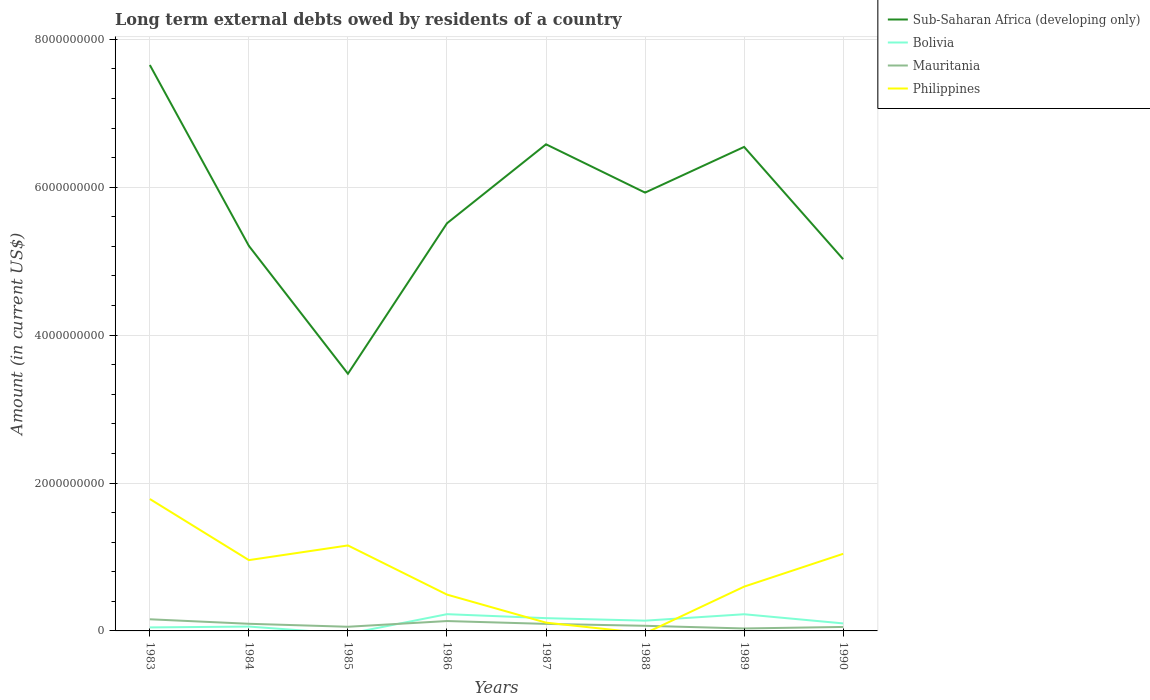How many different coloured lines are there?
Make the answer very short. 4. Does the line corresponding to Bolivia intersect with the line corresponding to Sub-Saharan Africa (developing only)?
Your response must be concise. No. What is the total amount of long-term external debts owed by residents in Bolivia in the graph?
Provide a succinct answer. -1.66e+08. What is the difference between the highest and the second highest amount of long-term external debts owed by residents in Philippines?
Your answer should be compact. 1.78e+09. What is the difference between the highest and the lowest amount of long-term external debts owed by residents in Mauritania?
Ensure brevity in your answer.  4. Is the amount of long-term external debts owed by residents in Sub-Saharan Africa (developing only) strictly greater than the amount of long-term external debts owed by residents in Bolivia over the years?
Provide a succinct answer. No. How many lines are there?
Provide a short and direct response. 4. How many years are there in the graph?
Give a very brief answer. 8. What is the difference between two consecutive major ticks on the Y-axis?
Offer a very short reply. 2.00e+09. Does the graph contain any zero values?
Give a very brief answer. Yes. How many legend labels are there?
Your answer should be compact. 4. How are the legend labels stacked?
Provide a short and direct response. Vertical. What is the title of the graph?
Keep it short and to the point. Long term external debts owed by residents of a country. Does "Isle of Man" appear as one of the legend labels in the graph?
Your answer should be very brief. No. What is the Amount (in current US$) in Sub-Saharan Africa (developing only) in 1983?
Offer a very short reply. 7.65e+09. What is the Amount (in current US$) of Bolivia in 1983?
Your answer should be compact. 4.74e+07. What is the Amount (in current US$) in Mauritania in 1983?
Provide a succinct answer. 1.57e+08. What is the Amount (in current US$) of Philippines in 1983?
Your response must be concise. 1.78e+09. What is the Amount (in current US$) of Sub-Saharan Africa (developing only) in 1984?
Make the answer very short. 5.21e+09. What is the Amount (in current US$) of Bolivia in 1984?
Give a very brief answer. 5.90e+07. What is the Amount (in current US$) in Mauritania in 1984?
Your answer should be compact. 9.66e+07. What is the Amount (in current US$) of Philippines in 1984?
Provide a short and direct response. 9.57e+08. What is the Amount (in current US$) of Sub-Saharan Africa (developing only) in 1985?
Keep it short and to the point. 3.48e+09. What is the Amount (in current US$) of Bolivia in 1985?
Keep it short and to the point. 0. What is the Amount (in current US$) of Mauritania in 1985?
Ensure brevity in your answer.  5.62e+07. What is the Amount (in current US$) in Philippines in 1985?
Your answer should be compact. 1.16e+09. What is the Amount (in current US$) of Sub-Saharan Africa (developing only) in 1986?
Make the answer very short. 5.51e+09. What is the Amount (in current US$) of Bolivia in 1986?
Offer a very short reply. 2.26e+08. What is the Amount (in current US$) in Mauritania in 1986?
Offer a terse response. 1.33e+08. What is the Amount (in current US$) of Philippines in 1986?
Your response must be concise. 4.91e+08. What is the Amount (in current US$) in Sub-Saharan Africa (developing only) in 1987?
Ensure brevity in your answer.  6.58e+09. What is the Amount (in current US$) in Bolivia in 1987?
Your answer should be compact. 1.73e+08. What is the Amount (in current US$) in Mauritania in 1987?
Offer a very short reply. 9.51e+07. What is the Amount (in current US$) of Philippines in 1987?
Offer a terse response. 1.12e+08. What is the Amount (in current US$) of Sub-Saharan Africa (developing only) in 1988?
Your answer should be very brief. 5.93e+09. What is the Amount (in current US$) of Bolivia in 1988?
Make the answer very short. 1.39e+08. What is the Amount (in current US$) of Mauritania in 1988?
Keep it short and to the point. 6.94e+07. What is the Amount (in current US$) in Philippines in 1988?
Give a very brief answer. 0. What is the Amount (in current US$) of Sub-Saharan Africa (developing only) in 1989?
Offer a very short reply. 6.55e+09. What is the Amount (in current US$) of Bolivia in 1989?
Ensure brevity in your answer.  2.25e+08. What is the Amount (in current US$) of Mauritania in 1989?
Provide a short and direct response. 3.32e+07. What is the Amount (in current US$) of Philippines in 1989?
Your answer should be compact. 5.99e+08. What is the Amount (in current US$) of Sub-Saharan Africa (developing only) in 1990?
Offer a very short reply. 5.03e+09. What is the Amount (in current US$) of Bolivia in 1990?
Provide a succinct answer. 1.02e+08. What is the Amount (in current US$) in Mauritania in 1990?
Keep it short and to the point. 5.39e+07. What is the Amount (in current US$) of Philippines in 1990?
Provide a succinct answer. 1.04e+09. Across all years, what is the maximum Amount (in current US$) of Sub-Saharan Africa (developing only)?
Offer a terse response. 7.65e+09. Across all years, what is the maximum Amount (in current US$) in Bolivia?
Provide a short and direct response. 2.26e+08. Across all years, what is the maximum Amount (in current US$) in Mauritania?
Offer a very short reply. 1.57e+08. Across all years, what is the maximum Amount (in current US$) in Philippines?
Keep it short and to the point. 1.78e+09. Across all years, what is the minimum Amount (in current US$) in Sub-Saharan Africa (developing only)?
Keep it short and to the point. 3.48e+09. Across all years, what is the minimum Amount (in current US$) of Bolivia?
Keep it short and to the point. 0. Across all years, what is the minimum Amount (in current US$) of Mauritania?
Your answer should be compact. 3.32e+07. What is the total Amount (in current US$) of Sub-Saharan Africa (developing only) in the graph?
Ensure brevity in your answer.  4.59e+1. What is the total Amount (in current US$) in Bolivia in the graph?
Make the answer very short. 9.71e+08. What is the total Amount (in current US$) in Mauritania in the graph?
Your response must be concise. 6.95e+08. What is the total Amount (in current US$) in Philippines in the graph?
Your answer should be very brief. 6.14e+09. What is the difference between the Amount (in current US$) of Sub-Saharan Africa (developing only) in 1983 and that in 1984?
Your answer should be very brief. 2.45e+09. What is the difference between the Amount (in current US$) in Bolivia in 1983 and that in 1984?
Ensure brevity in your answer.  -1.16e+07. What is the difference between the Amount (in current US$) of Mauritania in 1983 and that in 1984?
Make the answer very short. 6.09e+07. What is the difference between the Amount (in current US$) of Philippines in 1983 and that in 1984?
Your answer should be very brief. 8.26e+08. What is the difference between the Amount (in current US$) of Sub-Saharan Africa (developing only) in 1983 and that in 1985?
Your answer should be very brief. 4.17e+09. What is the difference between the Amount (in current US$) of Mauritania in 1983 and that in 1985?
Your answer should be very brief. 1.01e+08. What is the difference between the Amount (in current US$) in Philippines in 1983 and that in 1985?
Keep it short and to the point. 6.28e+08. What is the difference between the Amount (in current US$) in Sub-Saharan Africa (developing only) in 1983 and that in 1986?
Provide a short and direct response. 2.14e+09. What is the difference between the Amount (in current US$) of Bolivia in 1983 and that in 1986?
Ensure brevity in your answer.  -1.79e+08. What is the difference between the Amount (in current US$) of Mauritania in 1983 and that in 1986?
Your answer should be very brief. 2.40e+07. What is the difference between the Amount (in current US$) in Philippines in 1983 and that in 1986?
Provide a short and direct response. 1.29e+09. What is the difference between the Amount (in current US$) of Sub-Saharan Africa (developing only) in 1983 and that in 1987?
Provide a short and direct response. 1.07e+09. What is the difference between the Amount (in current US$) in Bolivia in 1983 and that in 1987?
Offer a terse response. -1.25e+08. What is the difference between the Amount (in current US$) of Mauritania in 1983 and that in 1987?
Ensure brevity in your answer.  6.23e+07. What is the difference between the Amount (in current US$) of Philippines in 1983 and that in 1987?
Your answer should be compact. 1.67e+09. What is the difference between the Amount (in current US$) of Sub-Saharan Africa (developing only) in 1983 and that in 1988?
Make the answer very short. 1.73e+09. What is the difference between the Amount (in current US$) of Bolivia in 1983 and that in 1988?
Ensure brevity in your answer.  -9.14e+07. What is the difference between the Amount (in current US$) of Mauritania in 1983 and that in 1988?
Offer a very short reply. 8.81e+07. What is the difference between the Amount (in current US$) of Sub-Saharan Africa (developing only) in 1983 and that in 1989?
Make the answer very short. 1.11e+09. What is the difference between the Amount (in current US$) in Bolivia in 1983 and that in 1989?
Make the answer very short. -1.78e+08. What is the difference between the Amount (in current US$) of Mauritania in 1983 and that in 1989?
Offer a terse response. 1.24e+08. What is the difference between the Amount (in current US$) of Philippines in 1983 and that in 1989?
Make the answer very short. 1.18e+09. What is the difference between the Amount (in current US$) in Sub-Saharan Africa (developing only) in 1983 and that in 1990?
Provide a succinct answer. 2.63e+09. What is the difference between the Amount (in current US$) of Bolivia in 1983 and that in 1990?
Provide a succinct answer. -5.42e+07. What is the difference between the Amount (in current US$) in Mauritania in 1983 and that in 1990?
Your answer should be very brief. 1.04e+08. What is the difference between the Amount (in current US$) of Philippines in 1983 and that in 1990?
Provide a short and direct response. 7.41e+08. What is the difference between the Amount (in current US$) in Sub-Saharan Africa (developing only) in 1984 and that in 1985?
Offer a very short reply. 1.73e+09. What is the difference between the Amount (in current US$) of Mauritania in 1984 and that in 1985?
Ensure brevity in your answer.  4.04e+07. What is the difference between the Amount (in current US$) of Philippines in 1984 and that in 1985?
Your response must be concise. -1.98e+08. What is the difference between the Amount (in current US$) in Sub-Saharan Africa (developing only) in 1984 and that in 1986?
Offer a terse response. -3.06e+08. What is the difference between the Amount (in current US$) in Bolivia in 1984 and that in 1986?
Give a very brief answer. -1.67e+08. What is the difference between the Amount (in current US$) of Mauritania in 1984 and that in 1986?
Ensure brevity in your answer.  -3.69e+07. What is the difference between the Amount (in current US$) in Philippines in 1984 and that in 1986?
Offer a terse response. 4.66e+08. What is the difference between the Amount (in current US$) in Sub-Saharan Africa (developing only) in 1984 and that in 1987?
Make the answer very short. -1.37e+09. What is the difference between the Amount (in current US$) of Bolivia in 1984 and that in 1987?
Offer a very short reply. -1.14e+08. What is the difference between the Amount (in current US$) in Mauritania in 1984 and that in 1987?
Make the answer very short. 1.46e+06. What is the difference between the Amount (in current US$) in Philippines in 1984 and that in 1987?
Provide a succinct answer. 8.46e+08. What is the difference between the Amount (in current US$) in Sub-Saharan Africa (developing only) in 1984 and that in 1988?
Your answer should be compact. -7.21e+08. What is the difference between the Amount (in current US$) of Bolivia in 1984 and that in 1988?
Your answer should be very brief. -7.97e+07. What is the difference between the Amount (in current US$) of Mauritania in 1984 and that in 1988?
Give a very brief answer. 2.72e+07. What is the difference between the Amount (in current US$) in Sub-Saharan Africa (developing only) in 1984 and that in 1989?
Offer a terse response. -1.34e+09. What is the difference between the Amount (in current US$) in Bolivia in 1984 and that in 1989?
Make the answer very short. -1.66e+08. What is the difference between the Amount (in current US$) of Mauritania in 1984 and that in 1989?
Keep it short and to the point. 6.34e+07. What is the difference between the Amount (in current US$) in Philippines in 1984 and that in 1989?
Make the answer very short. 3.59e+08. What is the difference between the Amount (in current US$) of Sub-Saharan Africa (developing only) in 1984 and that in 1990?
Your response must be concise. 1.80e+08. What is the difference between the Amount (in current US$) in Bolivia in 1984 and that in 1990?
Your answer should be very brief. -4.25e+07. What is the difference between the Amount (in current US$) in Mauritania in 1984 and that in 1990?
Keep it short and to the point. 4.27e+07. What is the difference between the Amount (in current US$) in Philippines in 1984 and that in 1990?
Your answer should be very brief. -8.54e+07. What is the difference between the Amount (in current US$) in Sub-Saharan Africa (developing only) in 1985 and that in 1986?
Provide a succinct answer. -2.03e+09. What is the difference between the Amount (in current US$) in Mauritania in 1985 and that in 1986?
Offer a very short reply. -7.73e+07. What is the difference between the Amount (in current US$) in Philippines in 1985 and that in 1986?
Provide a short and direct response. 6.65e+08. What is the difference between the Amount (in current US$) of Sub-Saharan Africa (developing only) in 1985 and that in 1987?
Offer a terse response. -3.10e+09. What is the difference between the Amount (in current US$) of Mauritania in 1985 and that in 1987?
Provide a short and direct response. -3.89e+07. What is the difference between the Amount (in current US$) in Philippines in 1985 and that in 1987?
Your answer should be very brief. 1.04e+09. What is the difference between the Amount (in current US$) in Sub-Saharan Africa (developing only) in 1985 and that in 1988?
Ensure brevity in your answer.  -2.45e+09. What is the difference between the Amount (in current US$) in Mauritania in 1985 and that in 1988?
Keep it short and to the point. -1.32e+07. What is the difference between the Amount (in current US$) of Sub-Saharan Africa (developing only) in 1985 and that in 1989?
Give a very brief answer. -3.07e+09. What is the difference between the Amount (in current US$) of Mauritania in 1985 and that in 1989?
Give a very brief answer. 2.30e+07. What is the difference between the Amount (in current US$) in Philippines in 1985 and that in 1989?
Ensure brevity in your answer.  5.57e+08. What is the difference between the Amount (in current US$) of Sub-Saharan Africa (developing only) in 1985 and that in 1990?
Offer a very short reply. -1.55e+09. What is the difference between the Amount (in current US$) in Mauritania in 1985 and that in 1990?
Give a very brief answer. 2.29e+06. What is the difference between the Amount (in current US$) in Philippines in 1985 and that in 1990?
Ensure brevity in your answer.  1.13e+08. What is the difference between the Amount (in current US$) in Sub-Saharan Africa (developing only) in 1986 and that in 1987?
Your answer should be compact. -1.07e+09. What is the difference between the Amount (in current US$) of Bolivia in 1986 and that in 1987?
Offer a terse response. 5.38e+07. What is the difference between the Amount (in current US$) of Mauritania in 1986 and that in 1987?
Give a very brief answer. 3.84e+07. What is the difference between the Amount (in current US$) of Philippines in 1986 and that in 1987?
Ensure brevity in your answer.  3.79e+08. What is the difference between the Amount (in current US$) of Sub-Saharan Africa (developing only) in 1986 and that in 1988?
Offer a very short reply. -4.15e+08. What is the difference between the Amount (in current US$) of Bolivia in 1986 and that in 1988?
Keep it short and to the point. 8.76e+07. What is the difference between the Amount (in current US$) in Mauritania in 1986 and that in 1988?
Your response must be concise. 6.41e+07. What is the difference between the Amount (in current US$) in Sub-Saharan Africa (developing only) in 1986 and that in 1989?
Keep it short and to the point. -1.03e+09. What is the difference between the Amount (in current US$) in Bolivia in 1986 and that in 1989?
Keep it short and to the point. 9.31e+05. What is the difference between the Amount (in current US$) of Mauritania in 1986 and that in 1989?
Your answer should be compact. 1.00e+08. What is the difference between the Amount (in current US$) in Philippines in 1986 and that in 1989?
Keep it short and to the point. -1.08e+08. What is the difference between the Amount (in current US$) of Sub-Saharan Africa (developing only) in 1986 and that in 1990?
Make the answer very short. 4.86e+08. What is the difference between the Amount (in current US$) of Bolivia in 1986 and that in 1990?
Make the answer very short. 1.25e+08. What is the difference between the Amount (in current US$) of Mauritania in 1986 and that in 1990?
Keep it short and to the point. 7.96e+07. What is the difference between the Amount (in current US$) of Philippines in 1986 and that in 1990?
Provide a short and direct response. -5.52e+08. What is the difference between the Amount (in current US$) in Sub-Saharan Africa (developing only) in 1987 and that in 1988?
Keep it short and to the point. 6.53e+08. What is the difference between the Amount (in current US$) of Bolivia in 1987 and that in 1988?
Your answer should be very brief. 3.38e+07. What is the difference between the Amount (in current US$) in Mauritania in 1987 and that in 1988?
Provide a short and direct response. 2.57e+07. What is the difference between the Amount (in current US$) in Sub-Saharan Africa (developing only) in 1987 and that in 1989?
Offer a terse response. 3.54e+07. What is the difference between the Amount (in current US$) in Bolivia in 1987 and that in 1989?
Your answer should be very brief. -5.29e+07. What is the difference between the Amount (in current US$) in Mauritania in 1987 and that in 1989?
Ensure brevity in your answer.  6.19e+07. What is the difference between the Amount (in current US$) of Philippines in 1987 and that in 1989?
Provide a succinct answer. -4.87e+08. What is the difference between the Amount (in current US$) of Sub-Saharan Africa (developing only) in 1987 and that in 1990?
Make the answer very short. 1.55e+09. What is the difference between the Amount (in current US$) in Bolivia in 1987 and that in 1990?
Provide a succinct answer. 7.10e+07. What is the difference between the Amount (in current US$) of Mauritania in 1987 and that in 1990?
Provide a succinct answer. 4.12e+07. What is the difference between the Amount (in current US$) of Philippines in 1987 and that in 1990?
Your answer should be very brief. -9.31e+08. What is the difference between the Amount (in current US$) in Sub-Saharan Africa (developing only) in 1988 and that in 1989?
Provide a succinct answer. -6.18e+08. What is the difference between the Amount (in current US$) in Bolivia in 1988 and that in 1989?
Provide a succinct answer. -8.67e+07. What is the difference between the Amount (in current US$) of Mauritania in 1988 and that in 1989?
Offer a terse response. 3.62e+07. What is the difference between the Amount (in current US$) of Sub-Saharan Africa (developing only) in 1988 and that in 1990?
Your answer should be compact. 9.01e+08. What is the difference between the Amount (in current US$) of Bolivia in 1988 and that in 1990?
Your answer should be compact. 3.72e+07. What is the difference between the Amount (in current US$) in Mauritania in 1988 and that in 1990?
Make the answer very short. 1.55e+07. What is the difference between the Amount (in current US$) in Sub-Saharan Africa (developing only) in 1989 and that in 1990?
Ensure brevity in your answer.  1.52e+09. What is the difference between the Amount (in current US$) in Bolivia in 1989 and that in 1990?
Provide a succinct answer. 1.24e+08. What is the difference between the Amount (in current US$) of Mauritania in 1989 and that in 1990?
Your response must be concise. -2.08e+07. What is the difference between the Amount (in current US$) of Philippines in 1989 and that in 1990?
Give a very brief answer. -4.44e+08. What is the difference between the Amount (in current US$) in Sub-Saharan Africa (developing only) in 1983 and the Amount (in current US$) in Bolivia in 1984?
Ensure brevity in your answer.  7.59e+09. What is the difference between the Amount (in current US$) of Sub-Saharan Africa (developing only) in 1983 and the Amount (in current US$) of Mauritania in 1984?
Ensure brevity in your answer.  7.56e+09. What is the difference between the Amount (in current US$) of Sub-Saharan Africa (developing only) in 1983 and the Amount (in current US$) of Philippines in 1984?
Provide a short and direct response. 6.70e+09. What is the difference between the Amount (in current US$) in Bolivia in 1983 and the Amount (in current US$) in Mauritania in 1984?
Provide a short and direct response. -4.92e+07. What is the difference between the Amount (in current US$) in Bolivia in 1983 and the Amount (in current US$) in Philippines in 1984?
Your answer should be compact. -9.10e+08. What is the difference between the Amount (in current US$) in Mauritania in 1983 and the Amount (in current US$) in Philippines in 1984?
Ensure brevity in your answer.  -8.00e+08. What is the difference between the Amount (in current US$) of Sub-Saharan Africa (developing only) in 1983 and the Amount (in current US$) of Mauritania in 1985?
Give a very brief answer. 7.60e+09. What is the difference between the Amount (in current US$) of Sub-Saharan Africa (developing only) in 1983 and the Amount (in current US$) of Philippines in 1985?
Your answer should be compact. 6.50e+09. What is the difference between the Amount (in current US$) of Bolivia in 1983 and the Amount (in current US$) of Mauritania in 1985?
Keep it short and to the point. -8.82e+06. What is the difference between the Amount (in current US$) in Bolivia in 1983 and the Amount (in current US$) in Philippines in 1985?
Make the answer very short. -1.11e+09. What is the difference between the Amount (in current US$) of Mauritania in 1983 and the Amount (in current US$) of Philippines in 1985?
Provide a succinct answer. -9.98e+08. What is the difference between the Amount (in current US$) of Sub-Saharan Africa (developing only) in 1983 and the Amount (in current US$) of Bolivia in 1986?
Provide a succinct answer. 7.43e+09. What is the difference between the Amount (in current US$) of Sub-Saharan Africa (developing only) in 1983 and the Amount (in current US$) of Mauritania in 1986?
Keep it short and to the point. 7.52e+09. What is the difference between the Amount (in current US$) of Sub-Saharan Africa (developing only) in 1983 and the Amount (in current US$) of Philippines in 1986?
Your answer should be compact. 7.16e+09. What is the difference between the Amount (in current US$) of Bolivia in 1983 and the Amount (in current US$) of Mauritania in 1986?
Your answer should be compact. -8.61e+07. What is the difference between the Amount (in current US$) in Bolivia in 1983 and the Amount (in current US$) in Philippines in 1986?
Your response must be concise. -4.44e+08. What is the difference between the Amount (in current US$) in Mauritania in 1983 and the Amount (in current US$) in Philippines in 1986?
Provide a succinct answer. -3.34e+08. What is the difference between the Amount (in current US$) in Sub-Saharan Africa (developing only) in 1983 and the Amount (in current US$) in Bolivia in 1987?
Your answer should be very brief. 7.48e+09. What is the difference between the Amount (in current US$) of Sub-Saharan Africa (developing only) in 1983 and the Amount (in current US$) of Mauritania in 1987?
Your answer should be compact. 7.56e+09. What is the difference between the Amount (in current US$) of Sub-Saharan Africa (developing only) in 1983 and the Amount (in current US$) of Philippines in 1987?
Offer a very short reply. 7.54e+09. What is the difference between the Amount (in current US$) of Bolivia in 1983 and the Amount (in current US$) of Mauritania in 1987?
Offer a terse response. -4.77e+07. What is the difference between the Amount (in current US$) of Bolivia in 1983 and the Amount (in current US$) of Philippines in 1987?
Your response must be concise. -6.44e+07. What is the difference between the Amount (in current US$) in Mauritania in 1983 and the Amount (in current US$) in Philippines in 1987?
Your answer should be compact. 4.56e+07. What is the difference between the Amount (in current US$) of Sub-Saharan Africa (developing only) in 1983 and the Amount (in current US$) of Bolivia in 1988?
Offer a terse response. 7.51e+09. What is the difference between the Amount (in current US$) of Sub-Saharan Africa (developing only) in 1983 and the Amount (in current US$) of Mauritania in 1988?
Give a very brief answer. 7.58e+09. What is the difference between the Amount (in current US$) of Bolivia in 1983 and the Amount (in current US$) of Mauritania in 1988?
Offer a terse response. -2.20e+07. What is the difference between the Amount (in current US$) of Sub-Saharan Africa (developing only) in 1983 and the Amount (in current US$) of Bolivia in 1989?
Offer a terse response. 7.43e+09. What is the difference between the Amount (in current US$) in Sub-Saharan Africa (developing only) in 1983 and the Amount (in current US$) in Mauritania in 1989?
Provide a succinct answer. 7.62e+09. What is the difference between the Amount (in current US$) in Sub-Saharan Africa (developing only) in 1983 and the Amount (in current US$) in Philippines in 1989?
Provide a short and direct response. 7.05e+09. What is the difference between the Amount (in current US$) in Bolivia in 1983 and the Amount (in current US$) in Mauritania in 1989?
Offer a terse response. 1.42e+07. What is the difference between the Amount (in current US$) of Bolivia in 1983 and the Amount (in current US$) of Philippines in 1989?
Ensure brevity in your answer.  -5.52e+08. What is the difference between the Amount (in current US$) of Mauritania in 1983 and the Amount (in current US$) of Philippines in 1989?
Your answer should be compact. -4.41e+08. What is the difference between the Amount (in current US$) in Sub-Saharan Africa (developing only) in 1983 and the Amount (in current US$) in Bolivia in 1990?
Offer a very short reply. 7.55e+09. What is the difference between the Amount (in current US$) in Sub-Saharan Africa (developing only) in 1983 and the Amount (in current US$) in Mauritania in 1990?
Offer a terse response. 7.60e+09. What is the difference between the Amount (in current US$) in Sub-Saharan Africa (developing only) in 1983 and the Amount (in current US$) in Philippines in 1990?
Offer a terse response. 6.61e+09. What is the difference between the Amount (in current US$) of Bolivia in 1983 and the Amount (in current US$) of Mauritania in 1990?
Your answer should be very brief. -6.53e+06. What is the difference between the Amount (in current US$) of Bolivia in 1983 and the Amount (in current US$) of Philippines in 1990?
Your answer should be very brief. -9.95e+08. What is the difference between the Amount (in current US$) in Mauritania in 1983 and the Amount (in current US$) in Philippines in 1990?
Your answer should be compact. -8.85e+08. What is the difference between the Amount (in current US$) in Sub-Saharan Africa (developing only) in 1984 and the Amount (in current US$) in Mauritania in 1985?
Your answer should be compact. 5.15e+09. What is the difference between the Amount (in current US$) in Sub-Saharan Africa (developing only) in 1984 and the Amount (in current US$) in Philippines in 1985?
Make the answer very short. 4.05e+09. What is the difference between the Amount (in current US$) in Bolivia in 1984 and the Amount (in current US$) in Mauritania in 1985?
Give a very brief answer. 2.83e+06. What is the difference between the Amount (in current US$) in Bolivia in 1984 and the Amount (in current US$) in Philippines in 1985?
Your response must be concise. -1.10e+09. What is the difference between the Amount (in current US$) of Mauritania in 1984 and the Amount (in current US$) of Philippines in 1985?
Ensure brevity in your answer.  -1.06e+09. What is the difference between the Amount (in current US$) of Sub-Saharan Africa (developing only) in 1984 and the Amount (in current US$) of Bolivia in 1986?
Keep it short and to the point. 4.98e+09. What is the difference between the Amount (in current US$) in Sub-Saharan Africa (developing only) in 1984 and the Amount (in current US$) in Mauritania in 1986?
Ensure brevity in your answer.  5.07e+09. What is the difference between the Amount (in current US$) in Sub-Saharan Africa (developing only) in 1984 and the Amount (in current US$) in Philippines in 1986?
Offer a very short reply. 4.72e+09. What is the difference between the Amount (in current US$) of Bolivia in 1984 and the Amount (in current US$) of Mauritania in 1986?
Give a very brief answer. -7.44e+07. What is the difference between the Amount (in current US$) of Bolivia in 1984 and the Amount (in current US$) of Philippines in 1986?
Offer a very short reply. -4.32e+08. What is the difference between the Amount (in current US$) of Mauritania in 1984 and the Amount (in current US$) of Philippines in 1986?
Make the answer very short. -3.94e+08. What is the difference between the Amount (in current US$) of Sub-Saharan Africa (developing only) in 1984 and the Amount (in current US$) of Bolivia in 1987?
Your answer should be very brief. 5.03e+09. What is the difference between the Amount (in current US$) in Sub-Saharan Africa (developing only) in 1984 and the Amount (in current US$) in Mauritania in 1987?
Ensure brevity in your answer.  5.11e+09. What is the difference between the Amount (in current US$) of Sub-Saharan Africa (developing only) in 1984 and the Amount (in current US$) of Philippines in 1987?
Provide a succinct answer. 5.09e+09. What is the difference between the Amount (in current US$) of Bolivia in 1984 and the Amount (in current US$) of Mauritania in 1987?
Your response must be concise. -3.61e+07. What is the difference between the Amount (in current US$) of Bolivia in 1984 and the Amount (in current US$) of Philippines in 1987?
Your answer should be compact. -5.28e+07. What is the difference between the Amount (in current US$) of Mauritania in 1984 and the Amount (in current US$) of Philippines in 1987?
Make the answer very short. -1.52e+07. What is the difference between the Amount (in current US$) of Sub-Saharan Africa (developing only) in 1984 and the Amount (in current US$) of Bolivia in 1988?
Keep it short and to the point. 5.07e+09. What is the difference between the Amount (in current US$) of Sub-Saharan Africa (developing only) in 1984 and the Amount (in current US$) of Mauritania in 1988?
Ensure brevity in your answer.  5.14e+09. What is the difference between the Amount (in current US$) in Bolivia in 1984 and the Amount (in current US$) in Mauritania in 1988?
Your answer should be compact. -1.04e+07. What is the difference between the Amount (in current US$) in Sub-Saharan Africa (developing only) in 1984 and the Amount (in current US$) in Bolivia in 1989?
Your answer should be compact. 4.98e+09. What is the difference between the Amount (in current US$) of Sub-Saharan Africa (developing only) in 1984 and the Amount (in current US$) of Mauritania in 1989?
Offer a very short reply. 5.17e+09. What is the difference between the Amount (in current US$) in Sub-Saharan Africa (developing only) in 1984 and the Amount (in current US$) in Philippines in 1989?
Give a very brief answer. 4.61e+09. What is the difference between the Amount (in current US$) in Bolivia in 1984 and the Amount (in current US$) in Mauritania in 1989?
Ensure brevity in your answer.  2.59e+07. What is the difference between the Amount (in current US$) in Bolivia in 1984 and the Amount (in current US$) in Philippines in 1989?
Offer a terse response. -5.40e+08. What is the difference between the Amount (in current US$) in Mauritania in 1984 and the Amount (in current US$) in Philippines in 1989?
Ensure brevity in your answer.  -5.02e+08. What is the difference between the Amount (in current US$) in Sub-Saharan Africa (developing only) in 1984 and the Amount (in current US$) in Bolivia in 1990?
Provide a succinct answer. 5.10e+09. What is the difference between the Amount (in current US$) of Sub-Saharan Africa (developing only) in 1984 and the Amount (in current US$) of Mauritania in 1990?
Provide a succinct answer. 5.15e+09. What is the difference between the Amount (in current US$) of Sub-Saharan Africa (developing only) in 1984 and the Amount (in current US$) of Philippines in 1990?
Your answer should be compact. 4.16e+09. What is the difference between the Amount (in current US$) in Bolivia in 1984 and the Amount (in current US$) in Mauritania in 1990?
Provide a short and direct response. 5.12e+06. What is the difference between the Amount (in current US$) in Bolivia in 1984 and the Amount (in current US$) in Philippines in 1990?
Offer a terse response. -9.84e+08. What is the difference between the Amount (in current US$) of Mauritania in 1984 and the Amount (in current US$) of Philippines in 1990?
Your answer should be compact. -9.46e+08. What is the difference between the Amount (in current US$) of Sub-Saharan Africa (developing only) in 1985 and the Amount (in current US$) of Bolivia in 1986?
Offer a very short reply. 3.25e+09. What is the difference between the Amount (in current US$) of Sub-Saharan Africa (developing only) in 1985 and the Amount (in current US$) of Mauritania in 1986?
Offer a terse response. 3.34e+09. What is the difference between the Amount (in current US$) in Sub-Saharan Africa (developing only) in 1985 and the Amount (in current US$) in Philippines in 1986?
Your response must be concise. 2.99e+09. What is the difference between the Amount (in current US$) in Mauritania in 1985 and the Amount (in current US$) in Philippines in 1986?
Provide a succinct answer. -4.35e+08. What is the difference between the Amount (in current US$) of Sub-Saharan Africa (developing only) in 1985 and the Amount (in current US$) of Bolivia in 1987?
Offer a very short reply. 3.31e+09. What is the difference between the Amount (in current US$) in Sub-Saharan Africa (developing only) in 1985 and the Amount (in current US$) in Mauritania in 1987?
Offer a terse response. 3.38e+09. What is the difference between the Amount (in current US$) of Sub-Saharan Africa (developing only) in 1985 and the Amount (in current US$) of Philippines in 1987?
Your response must be concise. 3.37e+09. What is the difference between the Amount (in current US$) in Mauritania in 1985 and the Amount (in current US$) in Philippines in 1987?
Provide a short and direct response. -5.56e+07. What is the difference between the Amount (in current US$) of Sub-Saharan Africa (developing only) in 1985 and the Amount (in current US$) of Bolivia in 1988?
Ensure brevity in your answer.  3.34e+09. What is the difference between the Amount (in current US$) in Sub-Saharan Africa (developing only) in 1985 and the Amount (in current US$) in Mauritania in 1988?
Make the answer very short. 3.41e+09. What is the difference between the Amount (in current US$) in Sub-Saharan Africa (developing only) in 1985 and the Amount (in current US$) in Bolivia in 1989?
Provide a succinct answer. 3.25e+09. What is the difference between the Amount (in current US$) in Sub-Saharan Africa (developing only) in 1985 and the Amount (in current US$) in Mauritania in 1989?
Offer a terse response. 3.44e+09. What is the difference between the Amount (in current US$) in Sub-Saharan Africa (developing only) in 1985 and the Amount (in current US$) in Philippines in 1989?
Keep it short and to the point. 2.88e+09. What is the difference between the Amount (in current US$) of Mauritania in 1985 and the Amount (in current US$) of Philippines in 1989?
Your answer should be compact. -5.43e+08. What is the difference between the Amount (in current US$) in Sub-Saharan Africa (developing only) in 1985 and the Amount (in current US$) in Bolivia in 1990?
Your answer should be compact. 3.38e+09. What is the difference between the Amount (in current US$) in Sub-Saharan Africa (developing only) in 1985 and the Amount (in current US$) in Mauritania in 1990?
Your answer should be very brief. 3.42e+09. What is the difference between the Amount (in current US$) of Sub-Saharan Africa (developing only) in 1985 and the Amount (in current US$) of Philippines in 1990?
Your answer should be compact. 2.44e+09. What is the difference between the Amount (in current US$) in Mauritania in 1985 and the Amount (in current US$) in Philippines in 1990?
Your response must be concise. -9.87e+08. What is the difference between the Amount (in current US$) in Sub-Saharan Africa (developing only) in 1986 and the Amount (in current US$) in Bolivia in 1987?
Your answer should be very brief. 5.34e+09. What is the difference between the Amount (in current US$) of Sub-Saharan Africa (developing only) in 1986 and the Amount (in current US$) of Mauritania in 1987?
Provide a short and direct response. 5.42e+09. What is the difference between the Amount (in current US$) of Sub-Saharan Africa (developing only) in 1986 and the Amount (in current US$) of Philippines in 1987?
Provide a succinct answer. 5.40e+09. What is the difference between the Amount (in current US$) of Bolivia in 1986 and the Amount (in current US$) of Mauritania in 1987?
Ensure brevity in your answer.  1.31e+08. What is the difference between the Amount (in current US$) of Bolivia in 1986 and the Amount (in current US$) of Philippines in 1987?
Your response must be concise. 1.15e+08. What is the difference between the Amount (in current US$) of Mauritania in 1986 and the Amount (in current US$) of Philippines in 1987?
Keep it short and to the point. 2.17e+07. What is the difference between the Amount (in current US$) of Sub-Saharan Africa (developing only) in 1986 and the Amount (in current US$) of Bolivia in 1988?
Keep it short and to the point. 5.37e+09. What is the difference between the Amount (in current US$) in Sub-Saharan Africa (developing only) in 1986 and the Amount (in current US$) in Mauritania in 1988?
Make the answer very short. 5.44e+09. What is the difference between the Amount (in current US$) in Bolivia in 1986 and the Amount (in current US$) in Mauritania in 1988?
Your response must be concise. 1.57e+08. What is the difference between the Amount (in current US$) in Sub-Saharan Africa (developing only) in 1986 and the Amount (in current US$) in Bolivia in 1989?
Your answer should be compact. 5.29e+09. What is the difference between the Amount (in current US$) in Sub-Saharan Africa (developing only) in 1986 and the Amount (in current US$) in Mauritania in 1989?
Offer a very short reply. 5.48e+09. What is the difference between the Amount (in current US$) of Sub-Saharan Africa (developing only) in 1986 and the Amount (in current US$) of Philippines in 1989?
Your response must be concise. 4.91e+09. What is the difference between the Amount (in current US$) of Bolivia in 1986 and the Amount (in current US$) of Mauritania in 1989?
Offer a very short reply. 1.93e+08. What is the difference between the Amount (in current US$) in Bolivia in 1986 and the Amount (in current US$) in Philippines in 1989?
Your answer should be very brief. -3.73e+08. What is the difference between the Amount (in current US$) of Mauritania in 1986 and the Amount (in current US$) of Philippines in 1989?
Provide a succinct answer. -4.65e+08. What is the difference between the Amount (in current US$) of Sub-Saharan Africa (developing only) in 1986 and the Amount (in current US$) of Bolivia in 1990?
Ensure brevity in your answer.  5.41e+09. What is the difference between the Amount (in current US$) in Sub-Saharan Africa (developing only) in 1986 and the Amount (in current US$) in Mauritania in 1990?
Your answer should be very brief. 5.46e+09. What is the difference between the Amount (in current US$) in Sub-Saharan Africa (developing only) in 1986 and the Amount (in current US$) in Philippines in 1990?
Offer a terse response. 4.47e+09. What is the difference between the Amount (in current US$) of Bolivia in 1986 and the Amount (in current US$) of Mauritania in 1990?
Your answer should be very brief. 1.72e+08. What is the difference between the Amount (in current US$) in Bolivia in 1986 and the Amount (in current US$) in Philippines in 1990?
Give a very brief answer. -8.16e+08. What is the difference between the Amount (in current US$) in Mauritania in 1986 and the Amount (in current US$) in Philippines in 1990?
Give a very brief answer. -9.09e+08. What is the difference between the Amount (in current US$) of Sub-Saharan Africa (developing only) in 1987 and the Amount (in current US$) of Bolivia in 1988?
Give a very brief answer. 6.44e+09. What is the difference between the Amount (in current US$) of Sub-Saharan Africa (developing only) in 1987 and the Amount (in current US$) of Mauritania in 1988?
Your answer should be compact. 6.51e+09. What is the difference between the Amount (in current US$) of Bolivia in 1987 and the Amount (in current US$) of Mauritania in 1988?
Your answer should be compact. 1.03e+08. What is the difference between the Amount (in current US$) of Sub-Saharan Africa (developing only) in 1987 and the Amount (in current US$) of Bolivia in 1989?
Ensure brevity in your answer.  6.36e+09. What is the difference between the Amount (in current US$) in Sub-Saharan Africa (developing only) in 1987 and the Amount (in current US$) in Mauritania in 1989?
Make the answer very short. 6.55e+09. What is the difference between the Amount (in current US$) in Sub-Saharan Africa (developing only) in 1987 and the Amount (in current US$) in Philippines in 1989?
Ensure brevity in your answer.  5.98e+09. What is the difference between the Amount (in current US$) in Bolivia in 1987 and the Amount (in current US$) in Mauritania in 1989?
Offer a very short reply. 1.39e+08. What is the difference between the Amount (in current US$) of Bolivia in 1987 and the Amount (in current US$) of Philippines in 1989?
Offer a terse response. -4.26e+08. What is the difference between the Amount (in current US$) of Mauritania in 1987 and the Amount (in current US$) of Philippines in 1989?
Ensure brevity in your answer.  -5.04e+08. What is the difference between the Amount (in current US$) of Sub-Saharan Africa (developing only) in 1987 and the Amount (in current US$) of Bolivia in 1990?
Your answer should be very brief. 6.48e+09. What is the difference between the Amount (in current US$) in Sub-Saharan Africa (developing only) in 1987 and the Amount (in current US$) in Mauritania in 1990?
Your answer should be very brief. 6.53e+09. What is the difference between the Amount (in current US$) in Sub-Saharan Africa (developing only) in 1987 and the Amount (in current US$) in Philippines in 1990?
Make the answer very short. 5.54e+09. What is the difference between the Amount (in current US$) of Bolivia in 1987 and the Amount (in current US$) of Mauritania in 1990?
Keep it short and to the point. 1.19e+08. What is the difference between the Amount (in current US$) of Bolivia in 1987 and the Amount (in current US$) of Philippines in 1990?
Ensure brevity in your answer.  -8.70e+08. What is the difference between the Amount (in current US$) of Mauritania in 1987 and the Amount (in current US$) of Philippines in 1990?
Your answer should be compact. -9.48e+08. What is the difference between the Amount (in current US$) in Sub-Saharan Africa (developing only) in 1988 and the Amount (in current US$) in Bolivia in 1989?
Provide a succinct answer. 5.70e+09. What is the difference between the Amount (in current US$) in Sub-Saharan Africa (developing only) in 1988 and the Amount (in current US$) in Mauritania in 1989?
Your answer should be very brief. 5.89e+09. What is the difference between the Amount (in current US$) of Sub-Saharan Africa (developing only) in 1988 and the Amount (in current US$) of Philippines in 1989?
Keep it short and to the point. 5.33e+09. What is the difference between the Amount (in current US$) of Bolivia in 1988 and the Amount (in current US$) of Mauritania in 1989?
Keep it short and to the point. 1.06e+08. What is the difference between the Amount (in current US$) of Bolivia in 1988 and the Amount (in current US$) of Philippines in 1989?
Your answer should be compact. -4.60e+08. What is the difference between the Amount (in current US$) of Mauritania in 1988 and the Amount (in current US$) of Philippines in 1989?
Give a very brief answer. -5.30e+08. What is the difference between the Amount (in current US$) of Sub-Saharan Africa (developing only) in 1988 and the Amount (in current US$) of Bolivia in 1990?
Your response must be concise. 5.83e+09. What is the difference between the Amount (in current US$) in Sub-Saharan Africa (developing only) in 1988 and the Amount (in current US$) in Mauritania in 1990?
Your answer should be very brief. 5.87e+09. What is the difference between the Amount (in current US$) of Sub-Saharan Africa (developing only) in 1988 and the Amount (in current US$) of Philippines in 1990?
Your answer should be compact. 4.88e+09. What is the difference between the Amount (in current US$) in Bolivia in 1988 and the Amount (in current US$) in Mauritania in 1990?
Your answer should be very brief. 8.49e+07. What is the difference between the Amount (in current US$) in Bolivia in 1988 and the Amount (in current US$) in Philippines in 1990?
Provide a short and direct response. -9.04e+08. What is the difference between the Amount (in current US$) of Mauritania in 1988 and the Amount (in current US$) of Philippines in 1990?
Make the answer very short. -9.73e+08. What is the difference between the Amount (in current US$) of Sub-Saharan Africa (developing only) in 1989 and the Amount (in current US$) of Bolivia in 1990?
Give a very brief answer. 6.44e+09. What is the difference between the Amount (in current US$) of Sub-Saharan Africa (developing only) in 1989 and the Amount (in current US$) of Mauritania in 1990?
Provide a succinct answer. 6.49e+09. What is the difference between the Amount (in current US$) of Sub-Saharan Africa (developing only) in 1989 and the Amount (in current US$) of Philippines in 1990?
Your response must be concise. 5.50e+09. What is the difference between the Amount (in current US$) of Bolivia in 1989 and the Amount (in current US$) of Mauritania in 1990?
Ensure brevity in your answer.  1.72e+08. What is the difference between the Amount (in current US$) in Bolivia in 1989 and the Amount (in current US$) in Philippines in 1990?
Your response must be concise. -8.17e+08. What is the difference between the Amount (in current US$) of Mauritania in 1989 and the Amount (in current US$) of Philippines in 1990?
Your answer should be compact. -1.01e+09. What is the average Amount (in current US$) in Sub-Saharan Africa (developing only) per year?
Provide a succinct answer. 5.74e+09. What is the average Amount (in current US$) of Bolivia per year?
Ensure brevity in your answer.  1.21e+08. What is the average Amount (in current US$) of Mauritania per year?
Make the answer very short. 8.69e+07. What is the average Amount (in current US$) of Philippines per year?
Offer a very short reply. 7.68e+08. In the year 1983, what is the difference between the Amount (in current US$) in Sub-Saharan Africa (developing only) and Amount (in current US$) in Bolivia?
Ensure brevity in your answer.  7.61e+09. In the year 1983, what is the difference between the Amount (in current US$) in Sub-Saharan Africa (developing only) and Amount (in current US$) in Mauritania?
Give a very brief answer. 7.50e+09. In the year 1983, what is the difference between the Amount (in current US$) in Sub-Saharan Africa (developing only) and Amount (in current US$) in Philippines?
Offer a very short reply. 5.87e+09. In the year 1983, what is the difference between the Amount (in current US$) in Bolivia and Amount (in current US$) in Mauritania?
Offer a very short reply. -1.10e+08. In the year 1983, what is the difference between the Amount (in current US$) of Bolivia and Amount (in current US$) of Philippines?
Ensure brevity in your answer.  -1.74e+09. In the year 1983, what is the difference between the Amount (in current US$) in Mauritania and Amount (in current US$) in Philippines?
Offer a very short reply. -1.63e+09. In the year 1984, what is the difference between the Amount (in current US$) in Sub-Saharan Africa (developing only) and Amount (in current US$) in Bolivia?
Make the answer very short. 5.15e+09. In the year 1984, what is the difference between the Amount (in current US$) of Sub-Saharan Africa (developing only) and Amount (in current US$) of Mauritania?
Make the answer very short. 5.11e+09. In the year 1984, what is the difference between the Amount (in current US$) in Sub-Saharan Africa (developing only) and Amount (in current US$) in Philippines?
Give a very brief answer. 4.25e+09. In the year 1984, what is the difference between the Amount (in current US$) of Bolivia and Amount (in current US$) of Mauritania?
Provide a short and direct response. -3.75e+07. In the year 1984, what is the difference between the Amount (in current US$) in Bolivia and Amount (in current US$) in Philippines?
Your response must be concise. -8.98e+08. In the year 1984, what is the difference between the Amount (in current US$) in Mauritania and Amount (in current US$) in Philippines?
Give a very brief answer. -8.61e+08. In the year 1985, what is the difference between the Amount (in current US$) of Sub-Saharan Africa (developing only) and Amount (in current US$) of Mauritania?
Your answer should be compact. 3.42e+09. In the year 1985, what is the difference between the Amount (in current US$) in Sub-Saharan Africa (developing only) and Amount (in current US$) in Philippines?
Offer a terse response. 2.32e+09. In the year 1985, what is the difference between the Amount (in current US$) of Mauritania and Amount (in current US$) of Philippines?
Offer a terse response. -1.10e+09. In the year 1986, what is the difference between the Amount (in current US$) in Sub-Saharan Africa (developing only) and Amount (in current US$) in Bolivia?
Provide a short and direct response. 5.29e+09. In the year 1986, what is the difference between the Amount (in current US$) in Sub-Saharan Africa (developing only) and Amount (in current US$) in Mauritania?
Give a very brief answer. 5.38e+09. In the year 1986, what is the difference between the Amount (in current US$) of Sub-Saharan Africa (developing only) and Amount (in current US$) of Philippines?
Keep it short and to the point. 5.02e+09. In the year 1986, what is the difference between the Amount (in current US$) of Bolivia and Amount (in current US$) of Mauritania?
Offer a very short reply. 9.29e+07. In the year 1986, what is the difference between the Amount (in current US$) of Bolivia and Amount (in current US$) of Philippines?
Provide a short and direct response. -2.65e+08. In the year 1986, what is the difference between the Amount (in current US$) in Mauritania and Amount (in current US$) in Philippines?
Make the answer very short. -3.58e+08. In the year 1987, what is the difference between the Amount (in current US$) in Sub-Saharan Africa (developing only) and Amount (in current US$) in Bolivia?
Ensure brevity in your answer.  6.41e+09. In the year 1987, what is the difference between the Amount (in current US$) of Sub-Saharan Africa (developing only) and Amount (in current US$) of Mauritania?
Provide a succinct answer. 6.49e+09. In the year 1987, what is the difference between the Amount (in current US$) in Sub-Saharan Africa (developing only) and Amount (in current US$) in Philippines?
Keep it short and to the point. 6.47e+09. In the year 1987, what is the difference between the Amount (in current US$) of Bolivia and Amount (in current US$) of Mauritania?
Provide a succinct answer. 7.75e+07. In the year 1987, what is the difference between the Amount (in current US$) of Bolivia and Amount (in current US$) of Philippines?
Provide a succinct answer. 6.08e+07. In the year 1987, what is the difference between the Amount (in current US$) of Mauritania and Amount (in current US$) of Philippines?
Keep it short and to the point. -1.67e+07. In the year 1988, what is the difference between the Amount (in current US$) in Sub-Saharan Africa (developing only) and Amount (in current US$) in Bolivia?
Provide a short and direct response. 5.79e+09. In the year 1988, what is the difference between the Amount (in current US$) of Sub-Saharan Africa (developing only) and Amount (in current US$) of Mauritania?
Offer a very short reply. 5.86e+09. In the year 1988, what is the difference between the Amount (in current US$) in Bolivia and Amount (in current US$) in Mauritania?
Offer a very short reply. 6.94e+07. In the year 1989, what is the difference between the Amount (in current US$) in Sub-Saharan Africa (developing only) and Amount (in current US$) in Bolivia?
Offer a terse response. 6.32e+09. In the year 1989, what is the difference between the Amount (in current US$) of Sub-Saharan Africa (developing only) and Amount (in current US$) of Mauritania?
Your answer should be compact. 6.51e+09. In the year 1989, what is the difference between the Amount (in current US$) in Sub-Saharan Africa (developing only) and Amount (in current US$) in Philippines?
Offer a very short reply. 5.95e+09. In the year 1989, what is the difference between the Amount (in current US$) of Bolivia and Amount (in current US$) of Mauritania?
Offer a very short reply. 1.92e+08. In the year 1989, what is the difference between the Amount (in current US$) in Bolivia and Amount (in current US$) in Philippines?
Your answer should be compact. -3.73e+08. In the year 1989, what is the difference between the Amount (in current US$) of Mauritania and Amount (in current US$) of Philippines?
Your response must be concise. -5.66e+08. In the year 1990, what is the difference between the Amount (in current US$) in Sub-Saharan Africa (developing only) and Amount (in current US$) in Bolivia?
Offer a terse response. 4.93e+09. In the year 1990, what is the difference between the Amount (in current US$) in Sub-Saharan Africa (developing only) and Amount (in current US$) in Mauritania?
Make the answer very short. 4.97e+09. In the year 1990, what is the difference between the Amount (in current US$) in Sub-Saharan Africa (developing only) and Amount (in current US$) in Philippines?
Provide a succinct answer. 3.98e+09. In the year 1990, what is the difference between the Amount (in current US$) of Bolivia and Amount (in current US$) of Mauritania?
Give a very brief answer. 4.77e+07. In the year 1990, what is the difference between the Amount (in current US$) of Bolivia and Amount (in current US$) of Philippines?
Make the answer very short. -9.41e+08. In the year 1990, what is the difference between the Amount (in current US$) in Mauritania and Amount (in current US$) in Philippines?
Provide a succinct answer. -9.89e+08. What is the ratio of the Amount (in current US$) in Sub-Saharan Africa (developing only) in 1983 to that in 1984?
Provide a succinct answer. 1.47. What is the ratio of the Amount (in current US$) of Bolivia in 1983 to that in 1984?
Your response must be concise. 0.8. What is the ratio of the Amount (in current US$) of Mauritania in 1983 to that in 1984?
Keep it short and to the point. 1.63. What is the ratio of the Amount (in current US$) of Philippines in 1983 to that in 1984?
Your answer should be very brief. 1.86. What is the ratio of the Amount (in current US$) of Sub-Saharan Africa (developing only) in 1983 to that in 1985?
Your answer should be compact. 2.2. What is the ratio of the Amount (in current US$) of Mauritania in 1983 to that in 1985?
Make the answer very short. 2.8. What is the ratio of the Amount (in current US$) of Philippines in 1983 to that in 1985?
Keep it short and to the point. 1.54. What is the ratio of the Amount (in current US$) of Sub-Saharan Africa (developing only) in 1983 to that in 1986?
Keep it short and to the point. 1.39. What is the ratio of the Amount (in current US$) in Bolivia in 1983 to that in 1986?
Your answer should be compact. 0.21. What is the ratio of the Amount (in current US$) of Mauritania in 1983 to that in 1986?
Your answer should be very brief. 1.18. What is the ratio of the Amount (in current US$) in Philippines in 1983 to that in 1986?
Your answer should be compact. 3.63. What is the ratio of the Amount (in current US$) in Sub-Saharan Africa (developing only) in 1983 to that in 1987?
Offer a terse response. 1.16. What is the ratio of the Amount (in current US$) in Bolivia in 1983 to that in 1987?
Provide a short and direct response. 0.27. What is the ratio of the Amount (in current US$) of Mauritania in 1983 to that in 1987?
Offer a terse response. 1.66. What is the ratio of the Amount (in current US$) in Philippines in 1983 to that in 1987?
Provide a short and direct response. 15.95. What is the ratio of the Amount (in current US$) of Sub-Saharan Africa (developing only) in 1983 to that in 1988?
Your answer should be compact. 1.29. What is the ratio of the Amount (in current US$) in Bolivia in 1983 to that in 1988?
Keep it short and to the point. 0.34. What is the ratio of the Amount (in current US$) in Mauritania in 1983 to that in 1988?
Your answer should be very brief. 2.27. What is the ratio of the Amount (in current US$) in Sub-Saharan Africa (developing only) in 1983 to that in 1989?
Ensure brevity in your answer.  1.17. What is the ratio of the Amount (in current US$) in Bolivia in 1983 to that in 1989?
Provide a succinct answer. 0.21. What is the ratio of the Amount (in current US$) of Mauritania in 1983 to that in 1989?
Provide a short and direct response. 4.75. What is the ratio of the Amount (in current US$) in Philippines in 1983 to that in 1989?
Your response must be concise. 2.98. What is the ratio of the Amount (in current US$) of Sub-Saharan Africa (developing only) in 1983 to that in 1990?
Make the answer very short. 1.52. What is the ratio of the Amount (in current US$) in Bolivia in 1983 to that in 1990?
Keep it short and to the point. 0.47. What is the ratio of the Amount (in current US$) of Mauritania in 1983 to that in 1990?
Provide a succinct answer. 2.92. What is the ratio of the Amount (in current US$) of Philippines in 1983 to that in 1990?
Keep it short and to the point. 1.71. What is the ratio of the Amount (in current US$) in Sub-Saharan Africa (developing only) in 1984 to that in 1985?
Provide a succinct answer. 1.5. What is the ratio of the Amount (in current US$) in Mauritania in 1984 to that in 1985?
Ensure brevity in your answer.  1.72. What is the ratio of the Amount (in current US$) of Philippines in 1984 to that in 1985?
Make the answer very short. 0.83. What is the ratio of the Amount (in current US$) in Sub-Saharan Africa (developing only) in 1984 to that in 1986?
Ensure brevity in your answer.  0.94. What is the ratio of the Amount (in current US$) of Bolivia in 1984 to that in 1986?
Ensure brevity in your answer.  0.26. What is the ratio of the Amount (in current US$) in Mauritania in 1984 to that in 1986?
Your answer should be very brief. 0.72. What is the ratio of the Amount (in current US$) of Philippines in 1984 to that in 1986?
Offer a terse response. 1.95. What is the ratio of the Amount (in current US$) of Sub-Saharan Africa (developing only) in 1984 to that in 1987?
Your answer should be compact. 0.79. What is the ratio of the Amount (in current US$) of Bolivia in 1984 to that in 1987?
Your response must be concise. 0.34. What is the ratio of the Amount (in current US$) of Mauritania in 1984 to that in 1987?
Your response must be concise. 1.02. What is the ratio of the Amount (in current US$) in Philippines in 1984 to that in 1987?
Make the answer very short. 8.56. What is the ratio of the Amount (in current US$) of Sub-Saharan Africa (developing only) in 1984 to that in 1988?
Provide a succinct answer. 0.88. What is the ratio of the Amount (in current US$) of Bolivia in 1984 to that in 1988?
Ensure brevity in your answer.  0.43. What is the ratio of the Amount (in current US$) of Mauritania in 1984 to that in 1988?
Provide a succinct answer. 1.39. What is the ratio of the Amount (in current US$) in Sub-Saharan Africa (developing only) in 1984 to that in 1989?
Keep it short and to the point. 0.8. What is the ratio of the Amount (in current US$) of Bolivia in 1984 to that in 1989?
Offer a terse response. 0.26. What is the ratio of the Amount (in current US$) of Mauritania in 1984 to that in 1989?
Offer a very short reply. 2.91. What is the ratio of the Amount (in current US$) in Philippines in 1984 to that in 1989?
Ensure brevity in your answer.  1.6. What is the ratio of the Amount (in current US$) in Sub-Saharan Africa (developing only) in 1984 to that in 1990?
Make the answer very short. 1.04. What is the ratio of the Amount (in current US$) in Bolivia in 1984 to that in 1990?
Your response must be concise. 0.58. What is the ratio of the Amount (in current US$) of Mauritania in 1984 to that in 1990?
Ensure brevity in your answer.  1.79. What is the ratio of the Amount (in current US$) in Philippines in 1984 to that in 1990?
Ensure brevity in your answer.  0.92. What is the ratio of the Amount (in current US$) of Sub-Saharan Africa (developing only) in 1985 to that in 1986?
Give a very brief answer. 0.63. What is the ratio of the Amount (in current US$) in Mauritania in 1985 to that in 1986?
Keep it short and to the point. 0.42. What is the ratio of the Amount (in current US$) in Philippines in 1985 to that in 1986?
Offer a terse response. 2.35. What is the ratio of the Amount (in current US$) in Sub-Saharan Africa (developing only) in 1985 to that in 1987?
Provide a short and direct response. 0.53. What is the ratio of the Amount (in current US$) of Mauritania in 1985 to that in 1987?
Keep it short and to the point. 0.59. What is the ratio of the Amount (in current US$) in Philippines in 1985 to that in 1987?
Ensure brevity in your answer.  10.34. What is the ratio of the Amount (in current US$) in Sub-Saharan Africa (developing only) in 1985 to that in 1988?
Ensure brevity in your answer.  0.59. What is the ratio of the Amount (in current US$) in Mauritania in 1985 to that in 1988?
Provide a succinct answer. 0.81. What is the ratio of the Amount (in current US$) in Sub-Saharan Africa (developing only) in 1985 to that in 1989?
Offer a very short reply. 0.53. What is the ratio of the Amount (in current US$) of Mauritania in 1985 to that in 1989?
Provide a succinct answer. 1.69. What is the ratio of the Amount (in current US$) in Philippines in 1985 to that in 1989?
Your response must be concise. 1.93. What is the ratio of the Amount (in current US$) in Sub-Saharan Africa (developing only) in 1985 to that in 1990?
Your answer should be very brief. 0.69. What is the ratio of the Amount (in current US$) in Mauritania in 1985 to that in 1990?
Offer a terse response. 1.04. What is the ratio of the Amount (in current US$) of Philippines in 1985 to that in 1990?
Your response must be concise. 1.11. What is the ratio of the Amount (in current US$) of Sub-Saharan Africa (developing only) in 1986 to that in 1987?
Offer a terse response. 0.84. What is the ratio of the Amount (in current US$) in Bolivia in 1986 to that in 1987?
Provide a succinct answer. 1.31. What is the ratio of the Amount (in current US$) in Mauritania in 1986 to that in 1987?
Give a very brief answer. 1.4. What is the ratio of the Amount (in current US$) in Philippines in 1986 to that in 1987?
Your response must be concise. 4.39. What is the ratio of the Amount (in current US$) in Bolivia in 1986 to that in 1988?
Offer a very short reply. 1.63. What is the ratio of the Amount (in current US$) in Mauritania in 1986 to that in 1988?
Make the answer very short. 1.92. What is the ratio of the Amount (in current US$) of Sub-Saharan Africa (developing only) in 1986 to that in 1989?
Provide a short and direct response. 0.84. What is the ratio of the Amount (in current US$) in Mauritania in 1986 to that in 1989?
Offer a very short reply. 4.02. What is the ratio of the Amount (in current US$) in Philippines in 1986 to that in 1989?
Offer a very short reply. 0.82. What is the ratio of the Amount (in current US$) in Sub-Saharan Africa (developing only) in 1986 to that in 1990?
Offer a very short reply. 1.1. What is the ratio of the Amount (in current US$) in Bolivia in 1986 to that in 1990?
Keep it short and to the point. 2.23. What is the ratio of the Amount (in current US$) of Mauritania in 1986 to that in 1990?
Ensure brevity in your answer.  2.48. What is the ratio of the Amount (in current US$) in Philippines in 1986 to that in 1990?
Offer a terse response. 0.47. What is the ratio of the Amount (in current US$) of Sub-Saharan Africa (developing only) in 1987 to that in 1988?
Make the answer very short. 1.11. What is the ratio of the Amount (in current US$) of Bolivia in 1987 to that in 1988?
Ensure brevity in your answer.  1.24. What is the ratio of the Amount (in current US$) of Mauritania in 1987 to that in 1988?
Provide a short and direct response. 1.37. What is the ratio of the Amount (in current US$) in Sub-Saharan Africa (developing only) in 1987 to that in 1989?
Provide a short and direct response. 1.01. What is the ratio of the Amount (in current US$) of Bolivia in 1987 to that in 1989?
Make the answer very short. 0.77. What is the ratio of the Amount (in current US$) of Mauritania in 1987 to that in 1989?
Provide a short and direct response. 2.87. What is the ratio of the Amount (in current US$) of Philippines in 1987 to that in 1989?
Ensure brevity in your answer.  0.19. What is the ratio of the Amount (in current US$) in Sub-Saharan Africa (developing only) in 1987 to that in 1990?
Provide a short and direct response. 1.31. What is the ratio of the Amount (in current US$) in Bolivia in 1987 to that in 1990?
Your answer should be very brief. 1.7. What is the ratio of the Amount (in current US$) of Mauritania in 1987 to that in 1990?
Provide a succinct answer. 1.76. What is the ratio of the Amount (in current US$) in Philippines in 1987 to that in 1990?
Offer a terse response. 0.11. What is the ratio of the Amount (in current US$) of Sub-Saharan Africa (developing only) in 1988 to that in 1989?
Provide a succinct answer. 0.91. What is the ratio of the Amount (in current US$) in Bolivia in 1988 to that in 1989?
Keep it short and to the point. 0.62. What is the ratio of the Amount (in current US$) of Mauritania in 1988 to that in 1989?
Your response must be concise. 2.09. What is the ratio of the Amount (in current US$) of Sub-Saharan Africa (developing only) in 1988 to that in 1990?
Ensure brevity in your answer.  1.18. What is the ratio of the Amount (in current US$) in Bolivia in 1988 to that in 1990?
Keep it short and to the point. 1.37. What is the ratio of the Amount (in current US$) of Mauritania in 1988 to that in 1990?
Keep it short and to the point. 1.29. What is the ratio of the Amount (in current US$) in Sub-Saharan Africa (developing only) in 1989 to that in 1990?
Provide a succinct answer. 1.3. What is the ratio of the Amount (in current US$) of Bolivia in 1989 to that in 1990?
Your answer should be very brief. 2.22. What is the ratio of the Amount (in current US$) of Mauritania in 1989 to that in 1990?
Provide a short and direct response. 0.62. What is the ratio of the Amount (in current US$) of Philippines in 1989 to that in 1990?
Ensure brevity in your answer.  0.57. What is the difference between the highest and the second highest Amount (in current US$) of Sub-Saharan Africa (developing only)?
Your answer should be compact. 1.07e+09. What is the difference between the highest and the second highest Amount (in current US$) in Bolivia?
Your answer should be very brief. 9.31e+05. What is the difference between the highest and the second highest Amount (in current US$) in Mauritania?
Your answer should be very brief. 2.40e+07. What is the difference between the highest and the second highest Amount (in current US$) of Philippines?
Your answer should be very brief. 6.28e+08. What is the difference between the highest and the lowest Amount (in current US$) of Sub-Saharan Africa (developing only)?
Provide a succinct answer. 4.17e+09. What is the difference between the highest and the lowest Amount (in current US$) in Bolivia?
Your answer should be very brief. 2.26e+08. What is the difference between the highest and the lowest Amount (in current US$) in Mauritania?
Make the answer very short. 1.24e+08. What is the difference between the highest and the lowest Amount (in current US$) in Philippines?
Keep it short and to the point. 1.78e+09. 